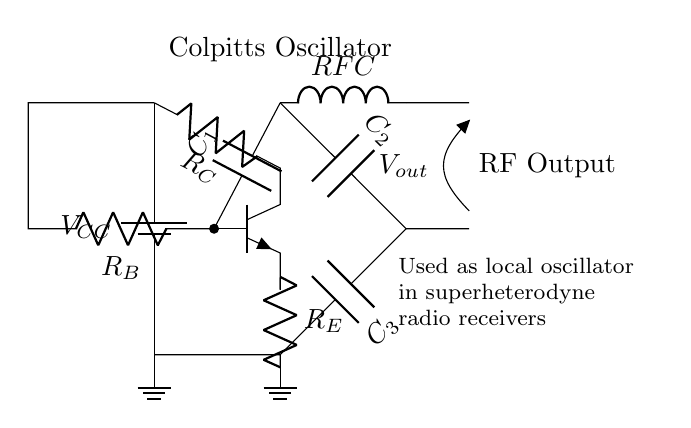What is the value of the power supply voltage? The circuit shows a battery symbol labeled with \( V_{CC} \), indicating the power supply voltage. However, the actual value is not specified in the diagram but is generally implied to be a standard voltage like 5V or 12V in many applications.
Answer: \( V_{CC} \) What is the function of the transistor in this oscillator? The transistor in the circuit is part of the oscillator circuit and serves as the amplifier to generate oscillations. It plays a crucial role in performing gain for the input signal which enables the oscillator to function.
Answer: Amplifier How many capacitors are present in the circuit? The diagram shows three capacitors labeled \( C_1 \), \( C_2 \), and \( C_3 \). Each capacitor is essential in forming the feedback network that is characteristic of a Colpitts oscillator.
Answer: Three What type of oscillator is represented by this circuit? The circuit is labeled clearly at the top as a "Colpitts Oscillator", which is a specific type of oscillator known for its unique feedback configuration utilizing capacitors and an inductor.
Answer: Colpitts What is the role of \( RFC \) in this circuit? The RF choke \( RFC \) is used in the circuit to block the RF (radio frequency) signals from going to the DC power supply while allowing DC current to flow to the transistor, effectively isolating the oscillator from load variations.
Answer: Isolation What is the purpose of the capacitors in the feedback network? The capacitors \( C_1 \), \( C_2 \), and \( C_3 \) are part of the feedback network which defines the frequency of oscillation and provides the necessary phase shift for sustained oscillations in the Colpitts oscillator configuration.
Answer: Frequency determination 